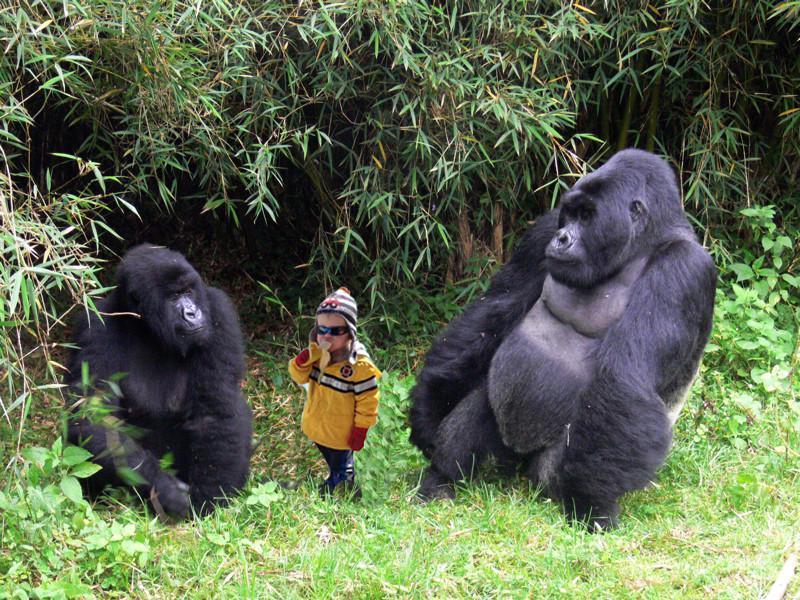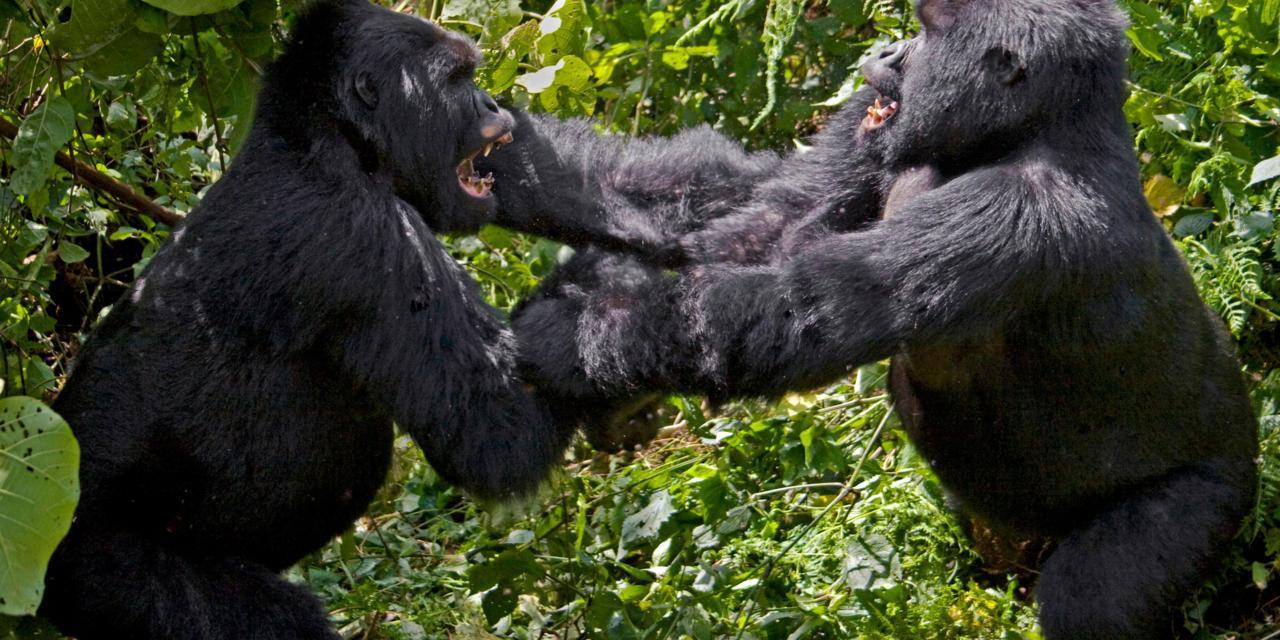The first image is the image on the left, the second image is the image on the right. Examine the images to the left and right. Is the description "One of the images features a lone male." accurate? Answer yes or no. No. The first image is the image on the left, the second image is the image on the right. Analyze the images presented: Is the assertion "One gorilla is carrying a baby gorilla on its back." valid? Answer yes or no. No. 